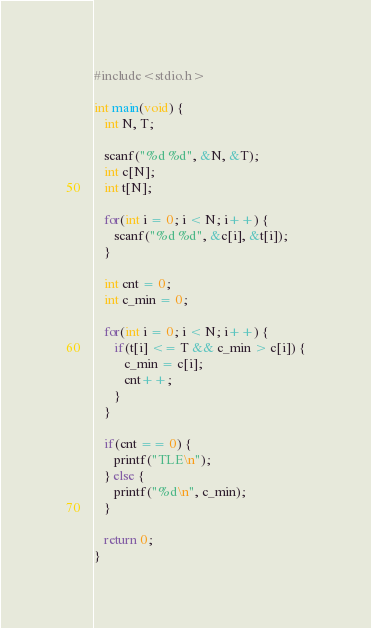Convert code to text. <code><loc_0><loc_0><loc_500><loc_500><_C_>#include<stdio.h>

int main(void) {
   int N, T;

   scanf("%d %d", &N, &T);
   int c[N];
   int t[N];

   for(int i = 0; i < N; i++) {
      scanf("%d %d", &c[i], &t[i]);
   }

   int cnt = 0;
   int c_min = 0;

   for(int i = 0; i < N; i++) {
      if(t[i] <= T && c_min > c[i]) {
         c_min = c[i];
         cnt++;
      }
   }

   if(cnt == 0) {
      printf("TLE\n");
   } else {
      printf("%d\n", c_min);
   }
   
   return 0;
}
</code> 